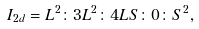Convert formula to latex. <formula><loc_0><loc_0><loc_500><loc_500>I _ { 2 d } = L ^ { 2 } \colon 3 L ^ { 2 } \colon 4 L S \colon 0 \colon S ^ { 2 } ,</formula> 